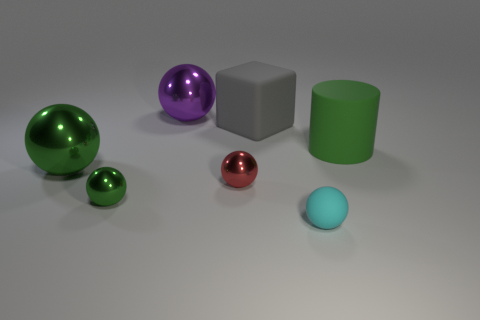Subtract all large green spheres. How many spheres are left? 4 Subtract all cyan spheres. How many spheres are left? 4 Add 3 large yellow matte objects. How many objects exist? 10 Subtract all blue balls. Subtract all green cylinders. How many balls are left? 5 Subtract all cylinders. How many objects are left? 6 Subtract all purple rubber blocks. Subtract all small metal objects. How many objects are left? 5 Add 6 purple balls. How many purple balls are left? 7 Add 1 blue rubber things. How many blue rubber things exist? 1 Subtract 0 brown cylinders. How many objects are left? 7 